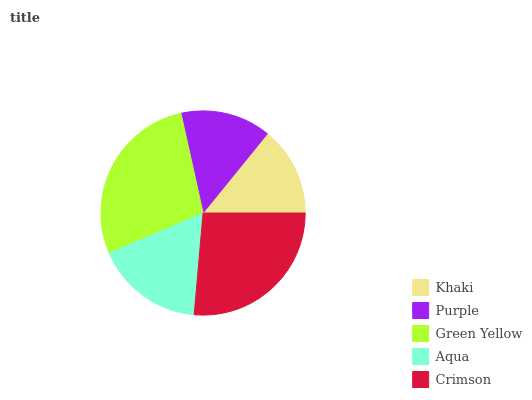Is Khaki the minimum?
Answer yes or no. Yes. Is Green Yellow the maximum?
Answer yes or no. Yes. Is Purple the minimum?
Answer yes or no. No. Is Purple the maximum?
Answer yes or no. No. Is Purple greater than Khaki?
Answer yes or no. Yes. Is Khaki less than Purple?
Answer yes or no. Yes. Is Khaki greater than Purple?
Answer yes or no. No. Is Purple less than Khaki?
Answer yes or no. No. Is Aqua the high median?
Answer yes or no. Yes. Is Aqua the low median?
Answer yes or no. Yes. Is Khaki the high median?
Answer yes or no. No. Is Purple the low median?
Answer yes or no. No. 